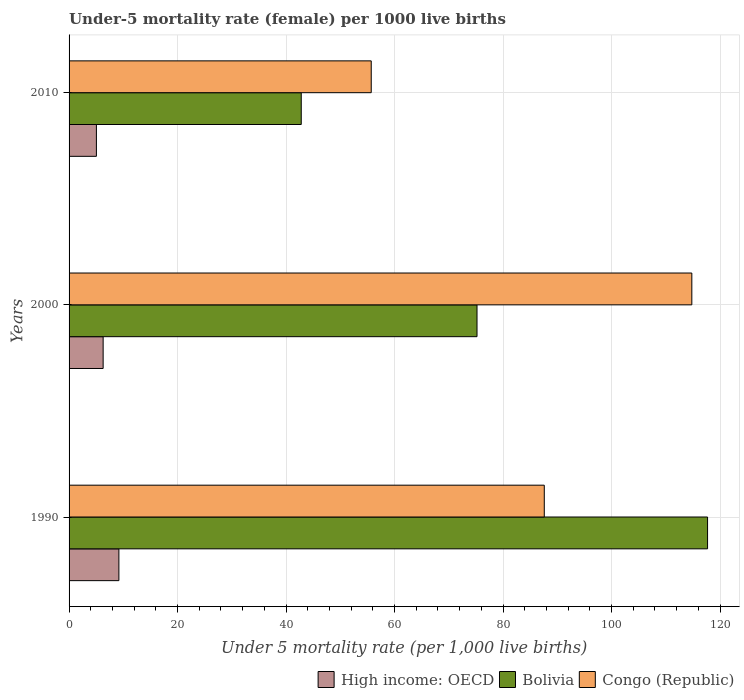How many groups of bars are there?
Provide a short and direct response. 3. Are the number of bars per tick equal to the number of legend labels?
Offer a terse response. Yes. Are the number of bars on each tick of the Y-axis equal?
Your answer should be compact. Yes. How many bars are there on the 1st tick from the top?
Give a very brief answer. 3. What is the label of the 3rd group of bars from the top?
Your answer should be very brief. 1990. In how many cases, is the number of bars for a given year not equal to the number of legend labels?
Provide a succinct answer. 0. What is the under-five mortality rate in Congo (Republic) in 2010?
Give a very brief answer. 55.7. Across all years, what is the maximum under-five mortality rate in High income: OECD?
Provide a succinct answer. 9.18. Across all years, what is the minimum under-five mortality rate in Congo (Republic)?
Your answer should be compact. 55.7. In which year was the under-five mortality rate in High income: OECD maximum?
Offer a terse response. 1990. What is the total under-five mortality rate in High income: OECD in the graph?
Your response must be concise. 20.5. What is the difference between the under-five mortality rate in Congo (Republic) in 1990 and that in 2000?
Offer a terse response. -27.2. What is the difference between the under-five mortality rate in Congo (Republic) in 2010 and the under-five mortality rate in High income: OECD in 2000?
Provide a short and direct response. 49.42. What is the average under-five mortality rate in Congo (Republic) per year?
Give a very brief answer. 86.03. In the year 2010, what is the difference between the under-five mortality rate in Bolivia and under-five mortality rate in Congo (Republic)?
Your response must be concise. -12.9. In how many years, is the under-five mortality rate in Bolivia greater than 104 ?
Offer a terse response. 1. What is the ratio of the under-five mortality rate in Bolivia in 1990 to that in 2010?
Your answer should be compact. 2.75. Is the difference between the under-five mortality rate in Bolivia in 1990 and 2000 greater than the difference between the under-five mortality rate in Congo (Republic) in 1990 and 2000?
Offer a terse response. Yes. What is the difference between the highest and the second highest under-five mortality rate in Bolivia?
Provide a short and direct response. 42.5. What is the difference between the highest and the lowest under-five mortality rate in Congo (Republic)?
Give a very brief answer. 59.1. What does the 2nd bar from the top in 1990 represents?
Your answer should be compact. Bolivia. What does the 3rd bar from the bottom in 2000 represents?
Give a very brief answer. Congo (Republic). Is it the case that in every year, the sum of the under-five mortality rate in Congo (Republic) and under-five mortality rate in Bolivia is greater than the under-five mortality rate in High income: OECD?
Keep it short and to the point. Yes. How many years are there in the graph?
Offer a very short reply. 3. Are the values on the major ticks of X-axis written in scientific E-notation?
Ensure brevity in your answer.  No. Does the graph contain grids?
Offer a terse response. Yes. Where does the legend appear in the graph?
Your response must be concise. Bottom right. How many legend labels are there?
Provide a short and direct response. 3. What is the title of the graph?
Make the answer very short. Under-5 mortality rate (female) per 1000 live births. Does "Sri Lanka" appear as one of the legend labels in the graph?
Your answer should be very brief. No. What is the label or title of the X-axis?
Keep it short and to the point. Under 5 mortality rate (per 1,0 live births). What is the Under 5 mortality rate (per 1,000 live births) in High income: OECD in 1990?
Keep it short and to the point. 9.18. What is the Under 5 mortality rate (per 1,000 live births) of Bolivia in 1990?
Make the answer very short. 117.7. What is the Under 5 mortality rate (per 1,000 live births) in Congo (Republic) in 1990?
Give a very brief answer. 87.6. What is the Under 5 mortality rate (per 1,000 live births) of High income: OECD in 2000?
Provide a succinct answer. 6.28. What is the Under 5 mortality rate (per 1,000 live births) in Bolivia in 2000?
Offer a very short reply. 75.2. What is the Under 5 mortality rate (per 1,000 live births) of Congo (Republic) in 2000?
Offer a very short reply. 114.8. What is the Under 5 mortality rate (per 1,000 live births) of High income: OECD in 2010?
Offer a very short reply. 5.04. What is the Under 5 mortality rate (per 1,000 live births) in Bolivia in 2010?
Keep it short and to the point. 42.8. What is the Under 5 mortality rate (per 1,000 live births) in Congo (Republic) in 2010?
Give a very brief answer. 55.7. Across all years, what is the maximum Under 5 mortality rate (per 1,000 live births) in High income: OECD?
Ensure brevity in your answer.  9.18. Across all years, what is the maximum Under 5 mortality rate (per 1,000 live births) in Bolivia?
Offer a terse response. 117.7. Across all years, what is the maximum Under 5 mortality rate (per 1,000 live births) in Congo (Republic)?
Offer a very short reply. 114.8. Across all years, what is the minimum Under 5 mortality rate (per 1,000 live births) of High income: OECD?
Make the answer very short. 5.04. Across all years, what is the minimum Under 5 mortality rate (per 1,000 live births) of Bolivia?
Your response must be concise. 42.8. Across all years, what is the minimum Under 5 mortality rate (per 1,000 live births) of Congo (Republic)?
Your response must be concise. 55.7. What is the total Under 5 mortality rate (per 1,000 live births) in High income: OECD in the graph?
Provide a succinct answer. 20.5. What is the total Under 5 mortality rate (per 1,000 live births) in Bolivia in the graph?
Your answer should be compact. 235.7. What is the total Under 5 mortality rate (per 1,000 live births) in Congo (Republic) in the graph?
Provide a succinct answer. 258.1. What is the difference between the Under 5 mortality rate (per 1,000 live births) in High income: OECD in 1990 and that in 2000?
Provide a succinct answer. 2.9. What is the difference between the Under 5 mortality rate (per 1,000 live births) in Bolivia in 1990 and that in 2000?
Provide a succinct answer. 42.5. What is the difference between the Under 5 mortality rate (per 1,000 live births) in Congo (Republic) in 1990 and that in 2000?
Your answer should be compact. -27.2. What is the difference between the Under 5 mortality rate (per 1,000 live births) of High income: OECD in 1990 and that in 2010?
Provide a succinct answer. 4.14. What is the difference between the Under 5 mortality rate (per 1,000 live births) in Bolivia in 1990 and that in 2010?
Make the answer very short. 74.9. What is the difference between the Under 5 mortality rate (per 1,000 live births) in Congo (Republic) in 1990 and that in 2010?
Give a very brief answer. 31.9. What is the difference between the Under 5 mortality rate (per 1,000 live births) in High income: OECD in 2000 and that in 2010?
Keep it short and to the point. 1.24. What is the difference between the Under 5 mortality rate (per 1,000 live births) in Bolivia in 2000 and that in 2010?
Provide a succinct answer. 32.4. What is the difference between the Under 5 mortality rate (per 1,000 live births) in Congo (Republic) in 2000 and that in 2010?
Your answer should be compact. 59.1. What is the difference between the Under 5 mortality rate (per 1,000 live births) of High income: OECD in 1990 and the Under 5 mortality rate (per 1,000 live births) of Bolivia in 2000?
Provide a succinct answer. -66.02. What is the difference between the Under 5 mortality rate (per 1,000 live births) in High income: OECD in 1990 and the Under 5 mortality rate (per 1,000 live births) in Congo (Republic) in 2000?
Offer a terse response. -105.62. What is the difference between the Under 5 mortality rate (per 1,000 live births) of Bolivia in 1990 and the Under 5 mortality rate (per 1,000 live births) of Congo (Republic) in 2000?
Your answer should be compact. 2.9. What is the difference between the Under 5 mortality rate (per 1,000 live births) in High income: OECD in 1990 and the Under 5 mortality rate (per 1,000 live births) in Bolivia in 2010?
Provide a succinct answer. -33.62. What is the difference between the Under 5 mortality rate (per 1,000 live births) in High income: OECD in 1990 and the Under 5 mortality rate (per 1,000 live births) in Congo (Republic) in 2010?
Keep it short and to the point. -46.52. What is the difference between the Under 5 mortality rate (per 1,000 live births) in Bolivia in 1990 and the Under 5 mortality rate (per 1,000 live births) in Congo (Republic) in 2010?
Provide a succinct answer. 62. What is the difference between the Under 5 mortality rate (per 1,000 live births) of High income: OECD in 2000 and the Under 5 mortality rate (per 1,000 live births) of Bolivia in 2010?
Ensure brevity in your answer.  -36.52. What is the difference between the Under 5 mortality rate (per 1,000 live births) in High income: OECD in 2000 and the Under 5 mortality rate (per 1,000 live births) in Congo (Republic) in 2010?
Your answer should be very brief. -49.42. What is the difference between the Under 5 mortality rate (per 1,000 live births) in Bolivia in 2000 and the Under 5 mortality rate (per 1,000 live births) in Congo (Republic) in 2010?
Offer a terse response. 19.5. What is the average Under 5 mortality rate (per 1,000 live births) in High income: OECD per year?
Keep it short and to the point. 6.83. What is the average Under 5 mortality rate (per 1,000 live births) of Bolivia per year?
Offer a terse response. 78.57. What is the average Under 5 mortality rate (per 1,000 live births) in Congo (Republic) per year?
Provide a short and direct response. 86.03. In the year 1990, what is the difference between the Under 5 mortality rate (per 1,000 live births) in High income: OECD and Under 5 mortality rate (per 1,000 live births) in Bolivia?
Your answer should be very brief. -108.52. In the year 1990, what is the difference between the Under 5 mortality rate (per 1,000 live births) of High income: OECD and Under 5 mortality rate (per 1,000 live births) of Congo (Republic)?
Your answer should be very brief. -78.42. In the year 1990, what is the difference between the Under 5 mortality rate (per 1,000 live births) of Bolivia and Under 5 mortality rate (per 1,000 live births) of Congo (Republic)?
Ensure brevity in your answer.  30.1. In the year 2000, what is the difference between the Under 5 mortality rate (per 1,000 live births) of High income: OECD and Under 5 mortality rate (per 1,000 live births) of Bolivia?
Make the answer very short. -68.92. In the year 2000, what is the difference between the Under 5 mortality rate (per 1,000 live births) in High income: OECD and Under 5 mortality rate (per 1,000 live births) in Congo (Republic)?
Keep it short and to the point. -108.52. In the year 2000, what is the difference between the Under 5 mortality rate (per 1,000 live births) in Bolivia and Under 5 mortality rate (per 1,000 live births) in Congo (Republic)?
Keep it short and to the point. -39.6. In the year 2010, what is the difference between the Under 5 mortality rate (per 1,000 live births) in High income: OECD and Under 5 mortality rate (per 1,000 live births) in Bolivia?
Offer a very short reply. -37.76. In the year 2010, what is the difference between the Under 5 mortality rate (per 1,000 live births) of High income: OECD and Under 5 mortality rate (per 1,000 live births) of Congo (Republic)?
Your answer should be very brief. -50.66. What is the ratio of the Under 5 mortality rate (per 1,000 live births) in High income: OECD in 1990 to that in 2000?
Your answer should be compact. 1.46. What is the ratio of the Under 5 mortality rate (per 1,000 live births) in Bolivia in 1990 to that in 2000?
Provide a succinct answer. 1.57. What is the ratio of the Under 5 mortality rate (per 1,000 live births) of Congo (Republic) in 1990 to that in 2000?
Provide a succinct answer. 0.76. What is the ratio of the Under 5 mortality rate (per 1,000 live births) of High income: OECD in 1990 to that in 2010?
Ensure brevity in your answer.  1.82. What is the ratio of the Under 5 mortality rate (per 1,000 live births) of Bolivia in 1990 to that in 2010?
Offer a terse response. 2.75. What is the ratio of the Under 5 mortality rate (per 1,000 live births) of Congo (Republic) in 1990 to that in 2010?
Offer a very short reply. 1.57. What is the ratio of the Under 5 mortality rate (per 1,000 live births) in High income: OECD in 2000 to that in 2010?
Provide a short and direct response. 1.25. What is the ratio of the Under 5 mortality rate (per 1,000 live births) of Bolivia in 2000 to that in 2010?
Provide a short and direct response. 1.76. What is the ratio of the Under 5 mortality rate (per 1,000 live births) of Congo (Republic) in 2000 to that in 2010?
Your answer should be compact. 2.06. What is the difference between the highest and the second highest Under 5 mortality rate (per 1,000 live births) of High income: OECD?
Your answer should be very brief. 2.9. What is the difference between the highest and the second highest Under 5 mortality rate (per 1,000 live births) of Bolivia?
Your response must be concise. 42.5. What is the difference between the highest and the second highest Under 5 mortality rate (per 1,000 live births) in Congo (Republic)?
Give a very brief answer. 27.2. What is the difference between the highest and the lowest Under 5 mortality rate (per 1,000 live births) in High income: OECD?
Your answer should be very brief. 4.14. What is the difference between the highest and the lowest Under 5 mortality rate (per 1,000 live births) in Bolivia?
Offer a very short reply. 74.9. What is the difference between the highest and the lowest Under 5 mortality rate (per 1,000 live births) in Congo (Republic)?
Your response must be concise. 59.1. 